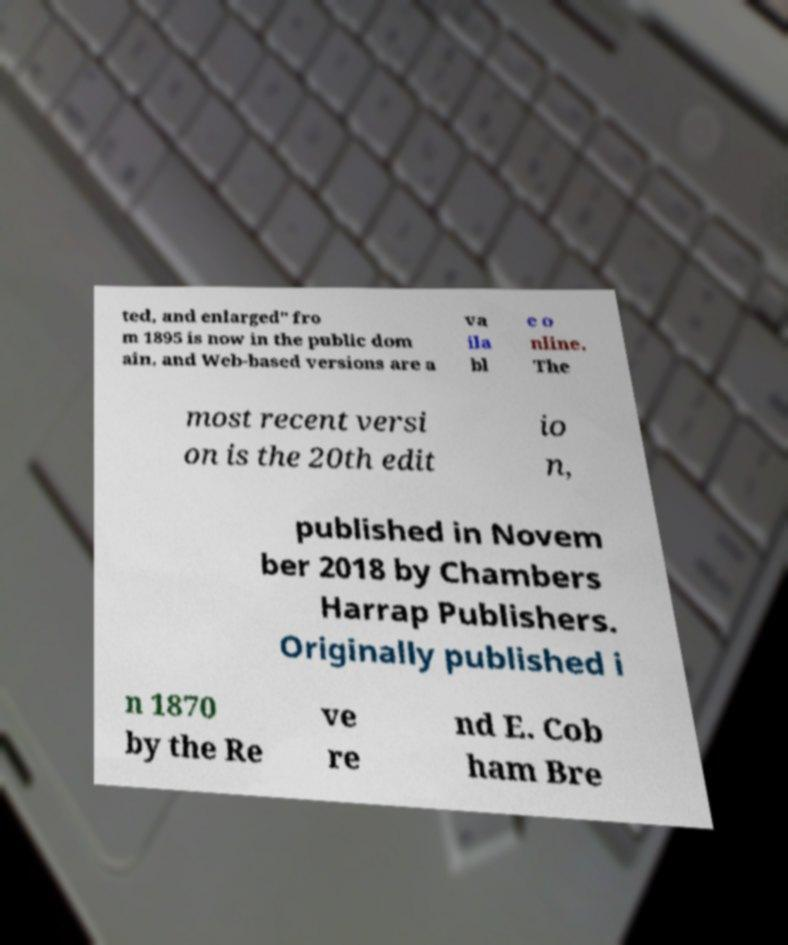What messages or text are displayed in this image? I need them in a readable, typed format. ted, and enlarged" fro m 1895 is now in the public dom ain, and Web-based versions are a va ila bl e o nline. The most recent versi on is the 20th edit io n, published in Novem ber 2018 by Chambers Harrap Publishers. Originally published i n 1870 by the Re ve re nd E. Cob ham Bre 